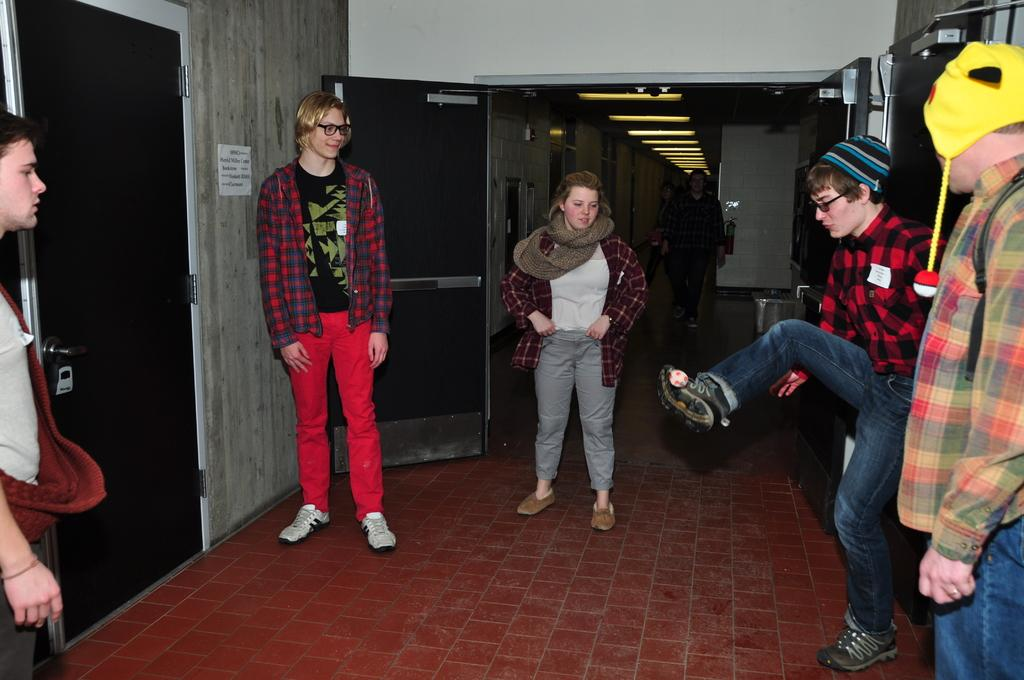What are the people in the image doing? There are people standing and walking in the image. Can you describe a specific action being performed by one of the people? A man is playing with a ball using his leg. Are any of the people wearing any specific type of clothing or accessory? Some men are wearing caps in the image. What architectural features can be seen in the image? There are doors visible in the image. How does the guide use the gold in the image? There is no guide or gold present in the image. What type of rub is being applied to the people in the image? There is no rubbing or any substance being applied to the people in the image. 